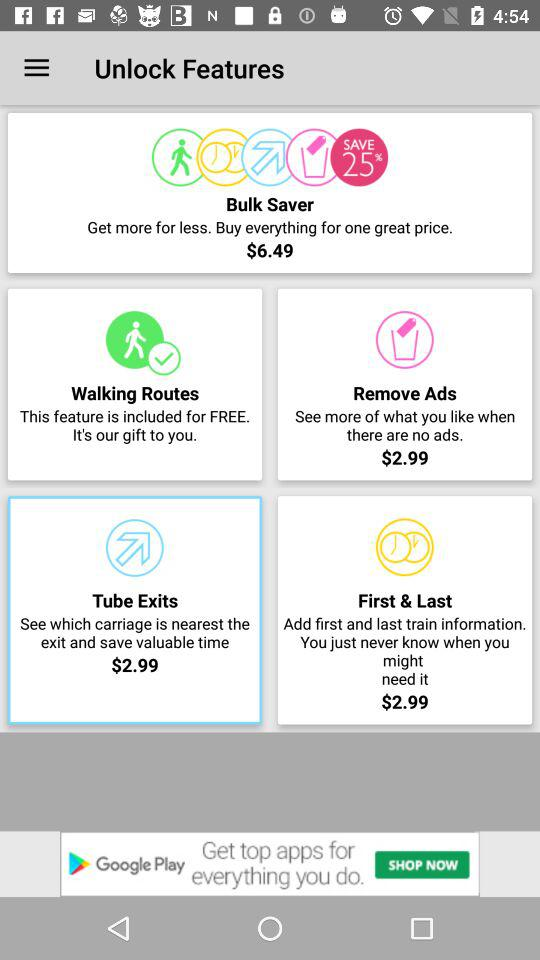How much is the price shown in "Tube Exits"? The price is $2.99. 